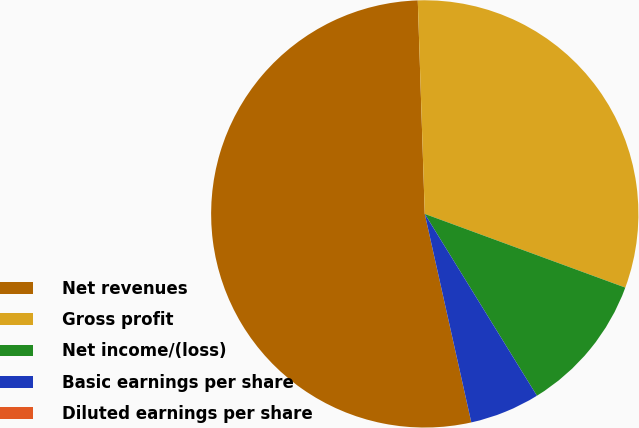<chart> <loc_0><loc_0><loc_500><loc_500><pie_chart><fcel>Net revenues<fcel>Gross profit<fcel>Net income/(loss)<fcel>Basic earnings per share<fcel>Diluted earnings per share<nl><fcel>52.98%<fcel>31.13%<fcel>10.6%<fcel>5.3%<fcel>0.0%<nl></chart> 